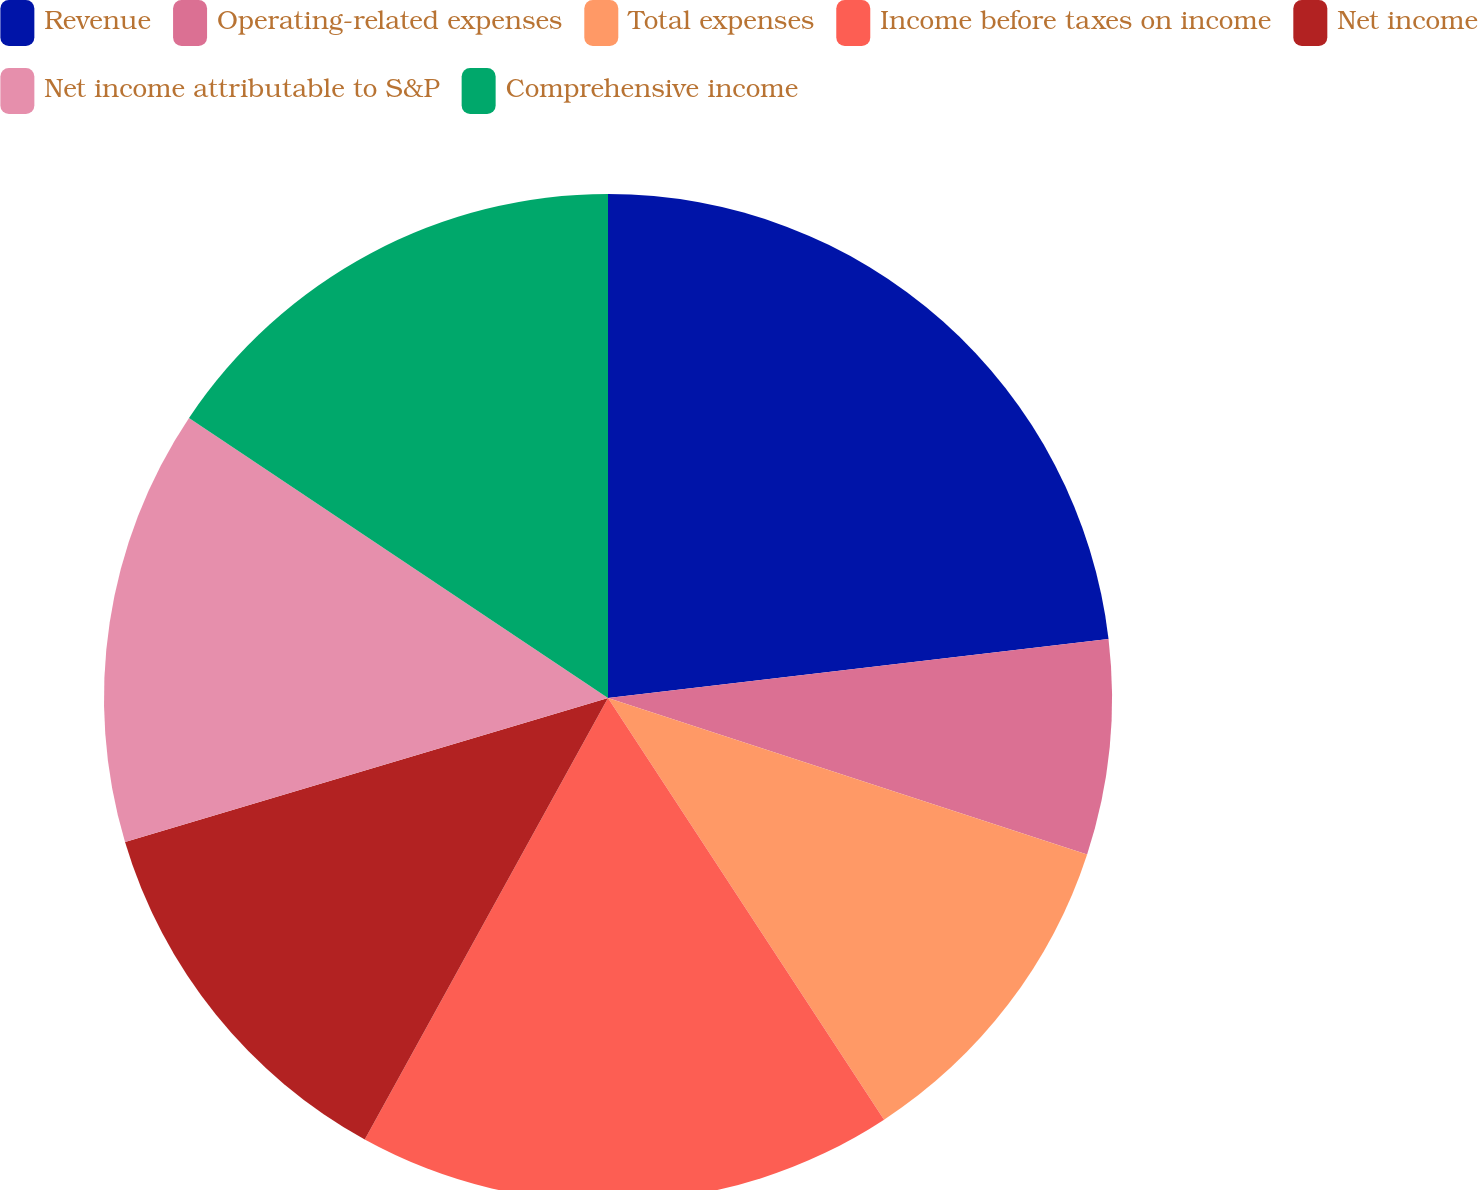Convert chart. <chart><loc_0><loc_0><loc_500><loc_500><pie_chart><fcel>Revenue<fcel>Operating-related expenses<fcel>Total expenses<fcel>Income before taxes on income<fcel>Net income<fcel>Net income attributable to S&P<fcel>Comprehensive income<nl><fcel>23.13%<fcel>6.89%<fcel>10.75%<fcel>17.24%<fcel>12.37%<fcel>13.99%<fcel>15.62%<nl></chart> 